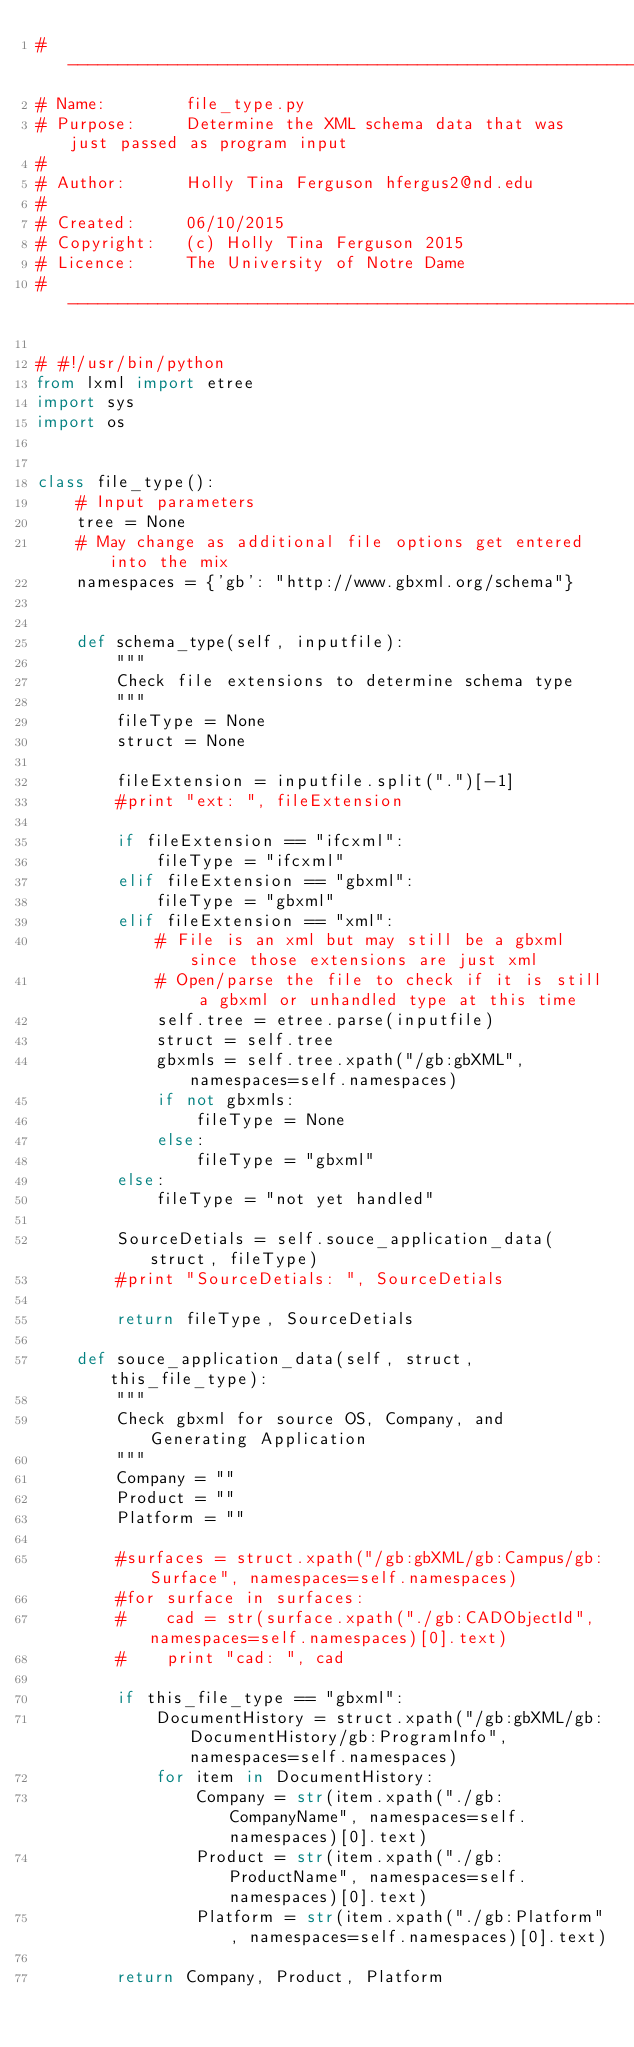<code> <loc_0><loc_0><loc_500><loc_500><_Python_>#-------------------------------------------------------------------------------
# Name:        file_type.py
# Purpose:     Determine the XML schema data that was just passed as program input
#
# Author:      Holly Tina Ferguson hfergus2@nd.edu
#
# Created:     06/10/2015
# Copyright:   (c) Holly Tina Ferguson 2015
# Licence:     The University of Notre Dame
#-------------------------------------------------------------------------------

# #!/usr/bin/python
from lxml import etree
import sys
import os


class file_type():
    # Input parameters
    tree = None
    # May change as additional file options get entered into the mix
    namespaces = {'gb': "http://www.gbxml.org/schema"}


    def schema_type(self, inputfile):
        """
        Check file extensions to determine schema type
        """
        fileType = None
        struct = None

        fileExtension = inputfile.split(".")[-1]
        #print "ext: ", fileExtension

        if fileExtension == "ifcxml":
            fileType = "ifcxml"
        elif fileExtension == "gbxml":
            fileType = "gbxml"
        elif fileExtension == "xml":
            # File is an xml but may still be a gbxml since those extensions are just xml
            # Open/parse the file to check if it is still a gbxml or unhandled type at this time
            self.tree = etree.parse(inputfile)
            struct = self.tree
            gbxmls = self.tree.xpath("/gb:gbXML", namespaces=self.namespaces)
            if not gbxmls:
                fileType = None
            else:
                fileType = "gbxml"
        else:
            fileType = "not yet handled"

        SourceDetials = self.souce_application_data(struct, fileType)
        #print "SourceDetials: ", SourceDetials

        return fileType, SourceDetials

    def souce_application_data(self, struct, this_file_type):
        """
        Check gbxml for source OS, Company, and Generating Application
        """
        Company = ""
        Product = ""
        Platform = ""

        #surfaces = struct.xpath("/gb:gbXML/gb:Campus/gb:Surface", namespaces=self.namespaces)
        #for surface in surfaces:
        #    cad = str(surface.xpath("./gb:CADObjectId", namespaces=self.namespaces)[0].text)
        #    print "cad: ", cad

        if this_file_type == "gbxml":
            DocumentHistory = struct.xpath("/gb:gbXML/gb:DocumentHistory/gb:ProgramInfo", namespaces=self.namespaces)
            for item in DocumentHistory:
                Company = str(item.xpath("./gb:CompanyName", namespaces=self.namespaces)[0].text)
                Product = str(item.xpath("./gb:ProductName", namespaces=self.namespaces)[0].text)
                Platform = str(item.xpath("./gb:Platform", namespaces=self.namespaces)[0].text)

        return Company, Product, Platform
</code> 